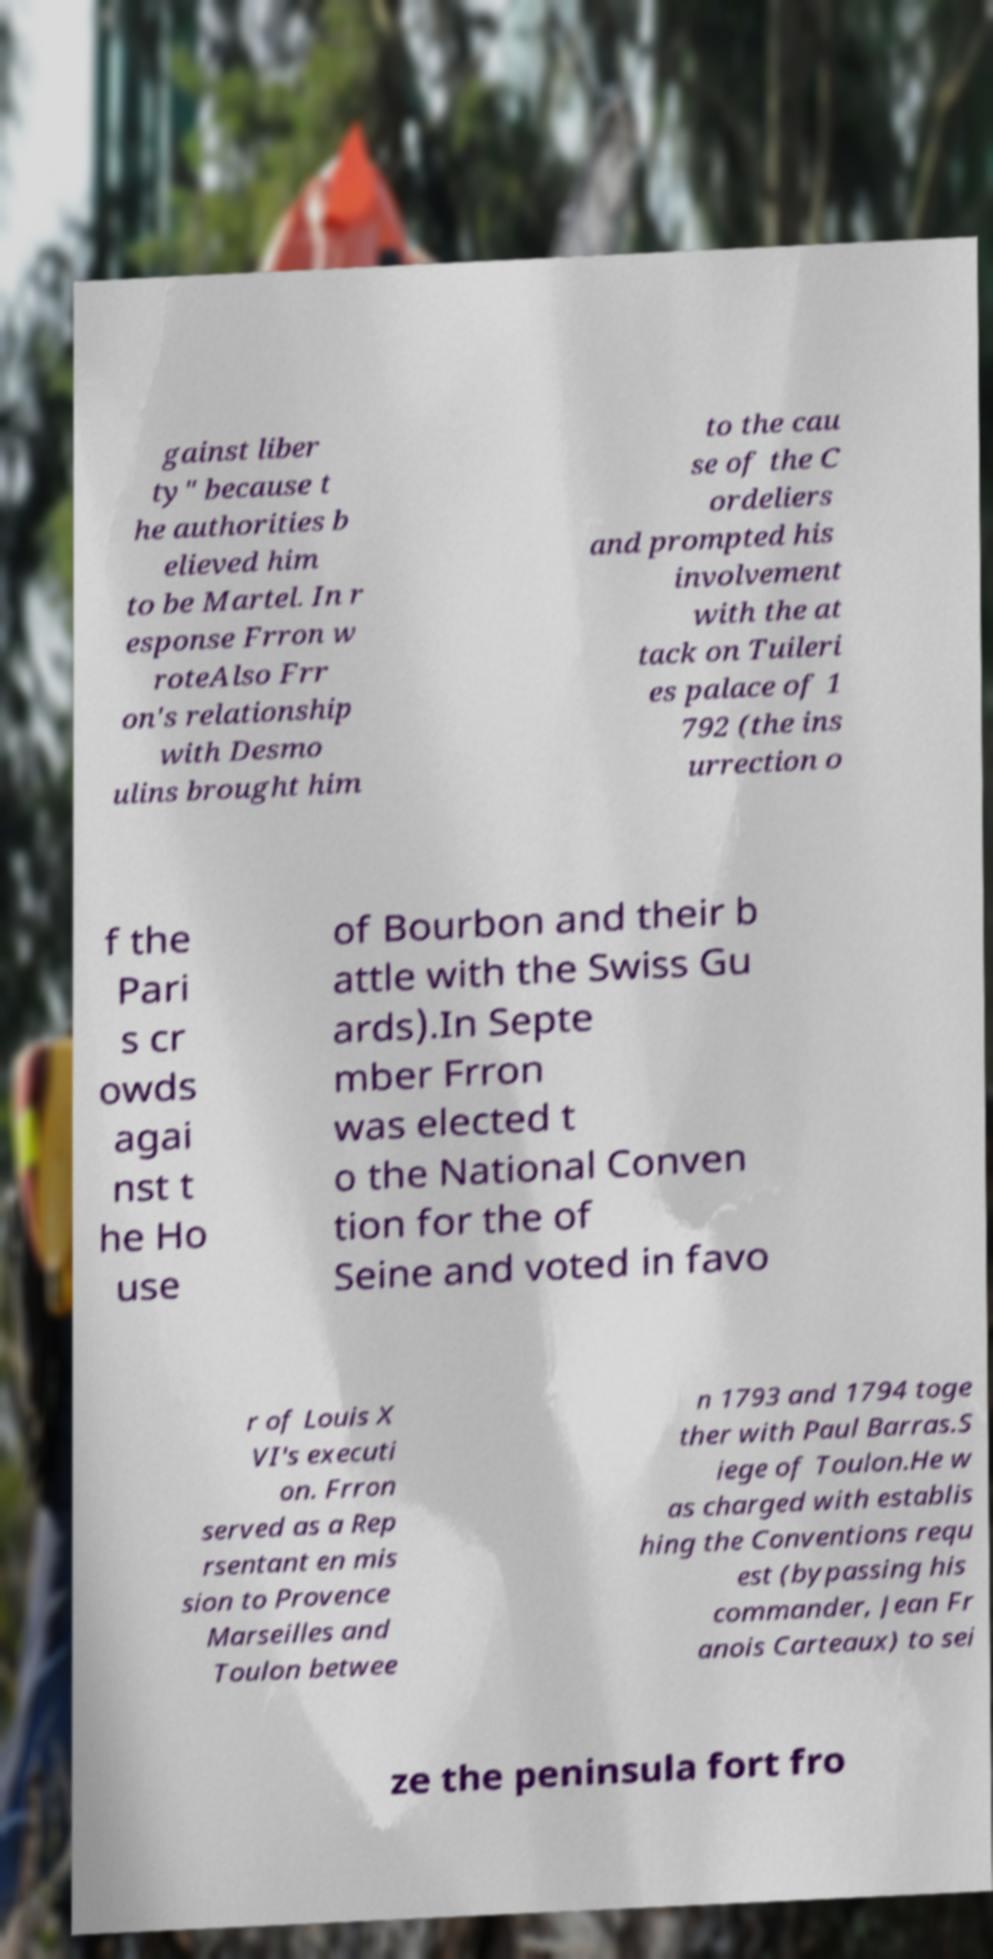Can you read and provide the text displayed in the image?This photo seems to have some interesting text. Can you extract and type it out for me? gainst liber ty" because t he authorities b elieved him to be Martel. In r esponse Frron w roteAlso Frr on's relationship with Desmo ulins brought him to the cau se of the C ordeliers and prompted his involvement with the at tack on Tuileri es palace of 1 792 (the ins urrection o f the Pari s cr owds agai nst t he Ho use of Bourbon and their b attle with the Swiss Gu ards).In Septe mber Frron was elected t o the National Conven tion for the of Seine and voted in favo r of Louis X VI's executi on. Frron served as a Rep rsentant en mis sion to Provence Marseilles and Toulon betwee n 1793 and 1794 toge ther with Paul Barras.S iege of Toulon.He w as charged with establis hing the Conventions requ est (bypassing his commander, Jean Fr anois Carteaux) to sei ze the peninsula fort fro 